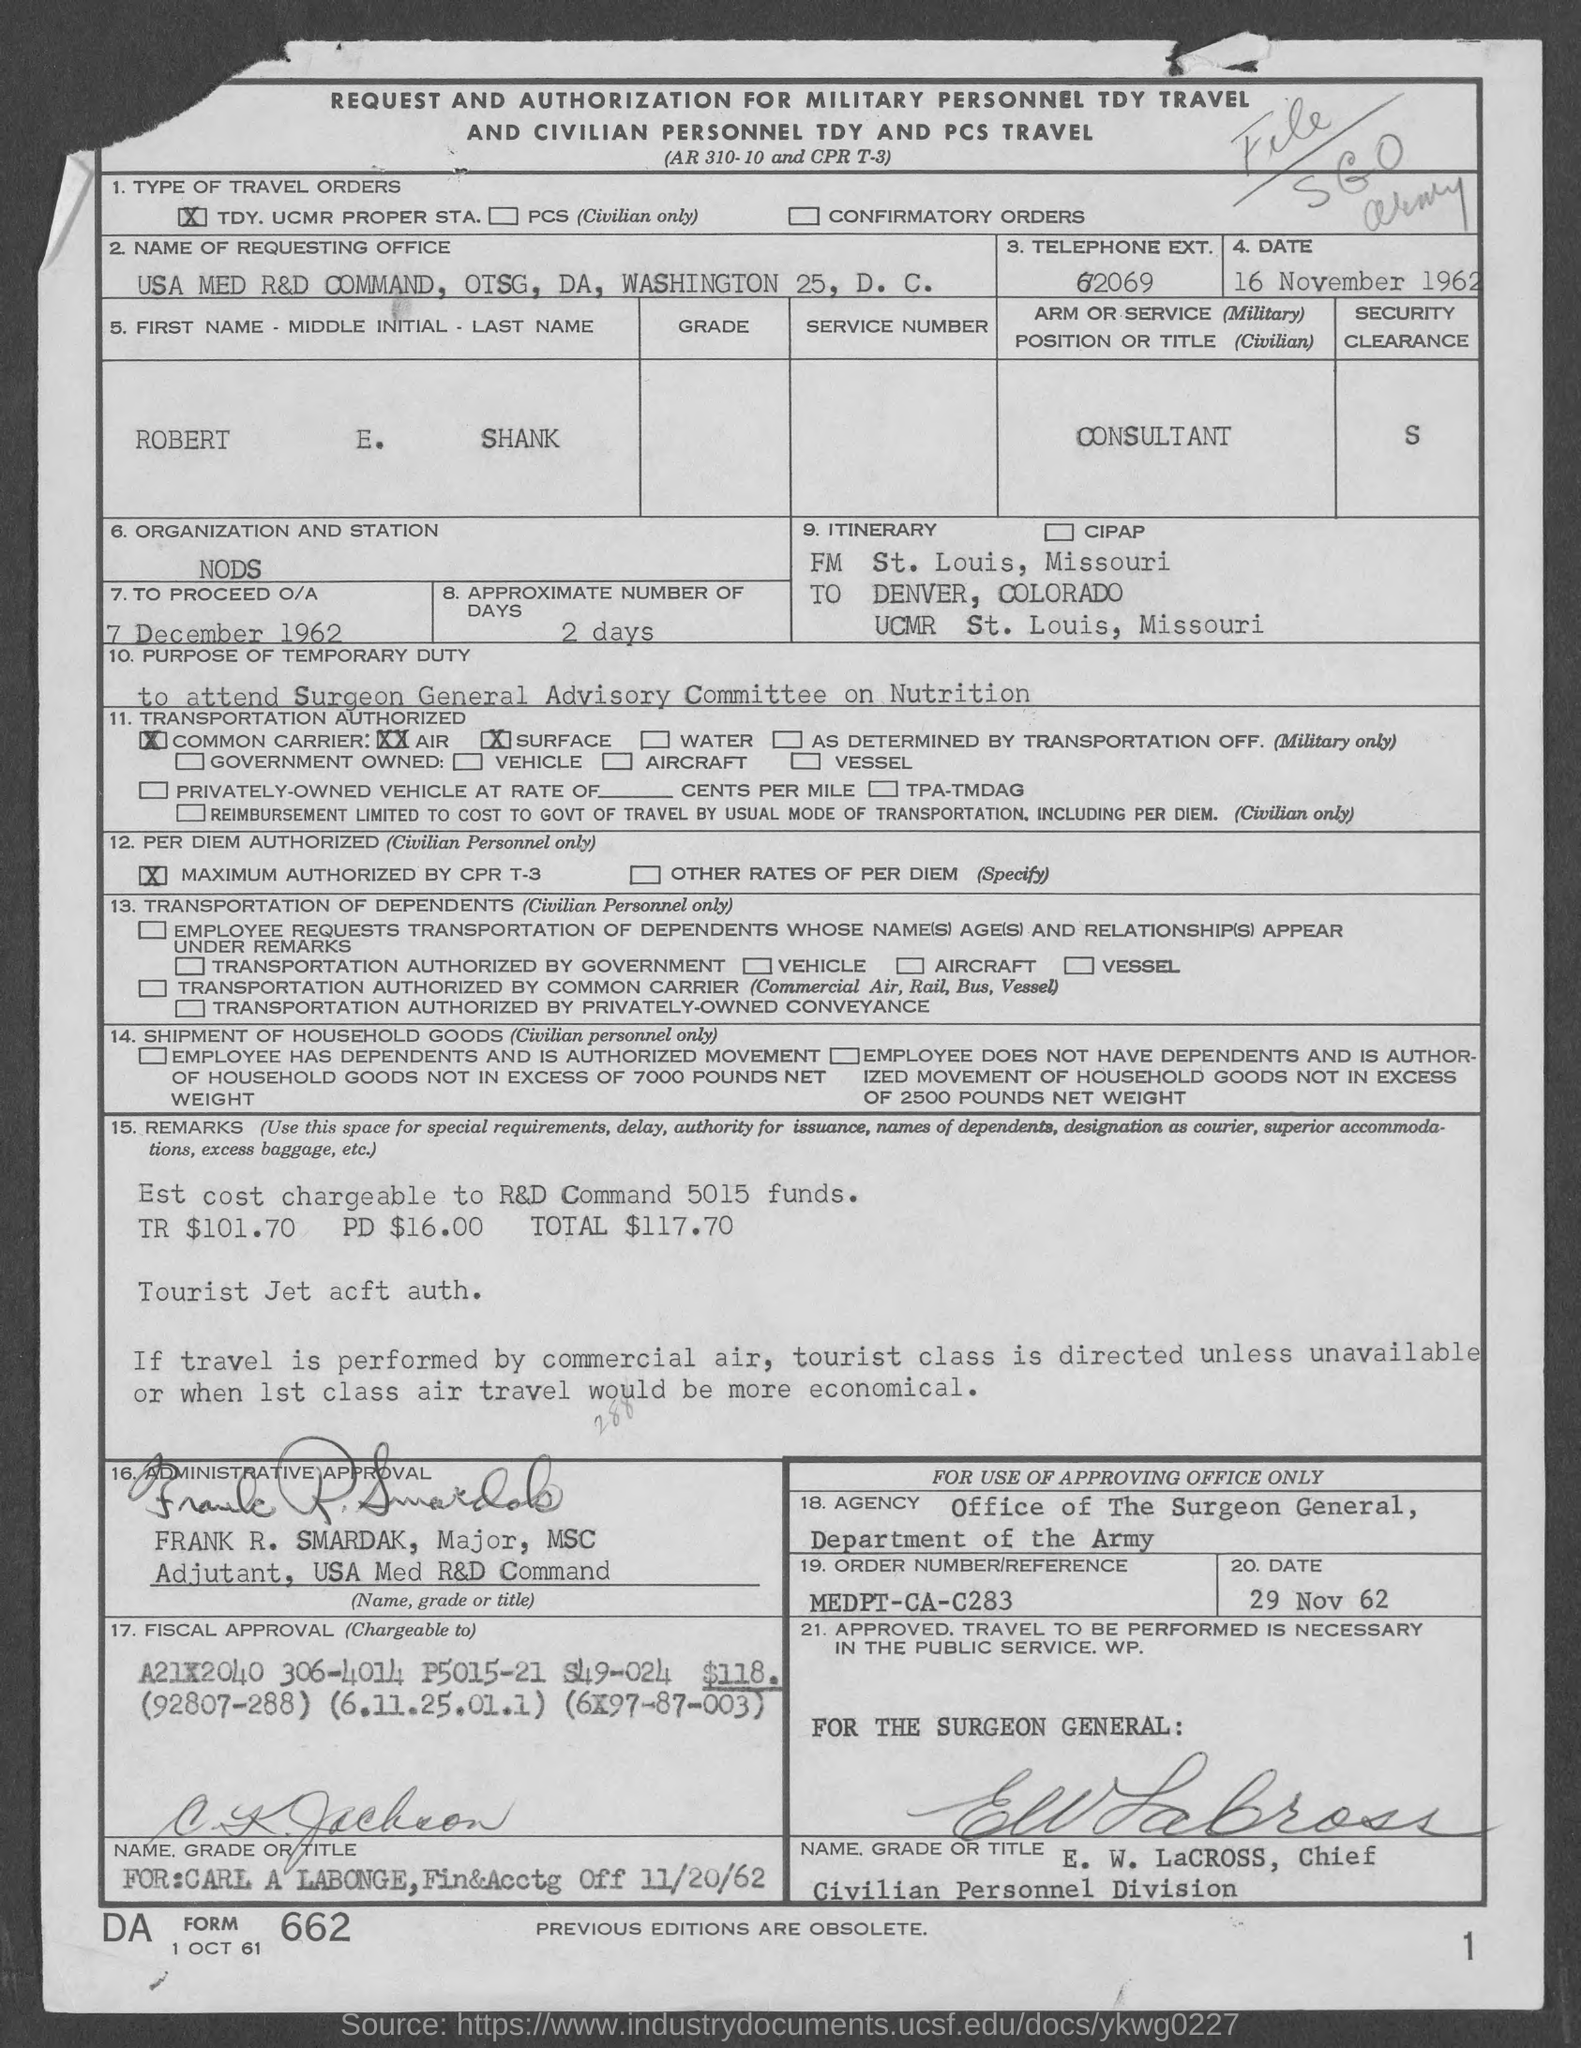Point out several critical features in this image. The date is 16 November 1962. I, [Name], am a consultant with the arm or service position of [Title]. As of approximately 2 days ago, there are approximately 2 days remaining. I would like to know the telephone extension given for 62069... 